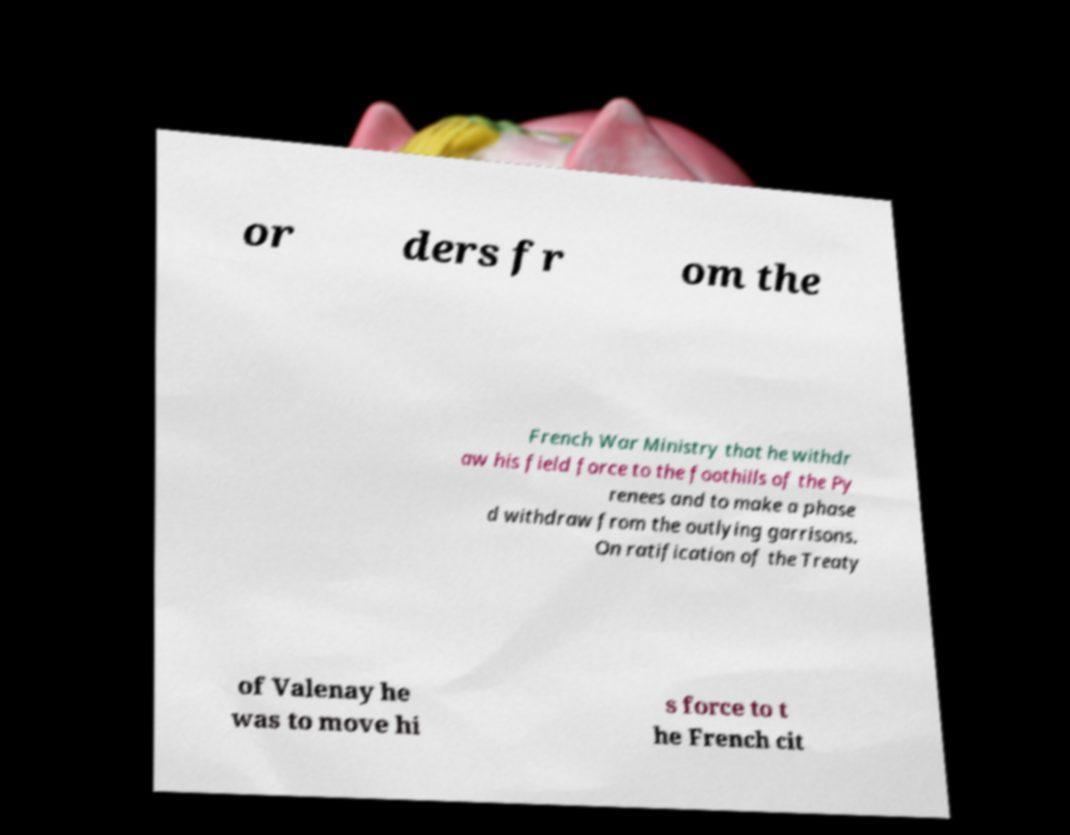Can you read and provide the text displayed in the image?This photo seems to have some interesting text. Can you extract and type it out for me? or ders fr om the French War Ministry that he withdr aw his field force to the foothills of the Py renees and to make a phase d withdraw from the outlying garrisons. On ratification of the Treaty of Valenay he was to move hi s force to t he French cit 